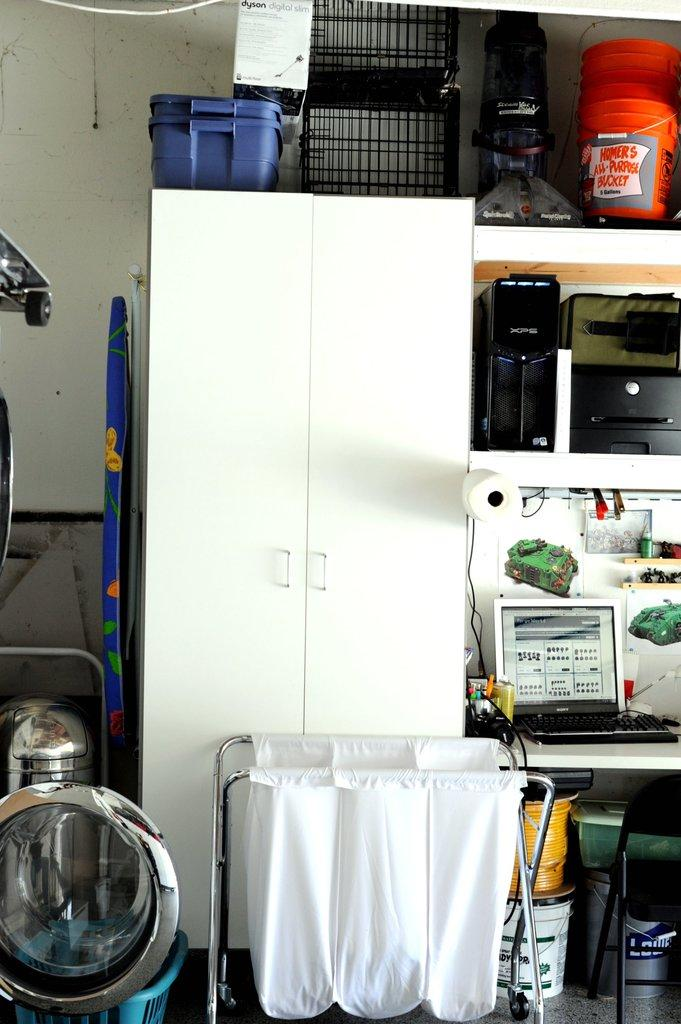<image>
Offer a succinct explanation of the picture presented. An orange bucket, labelled Homer's All-Purpose Bucket, is seen atop a shelf. 